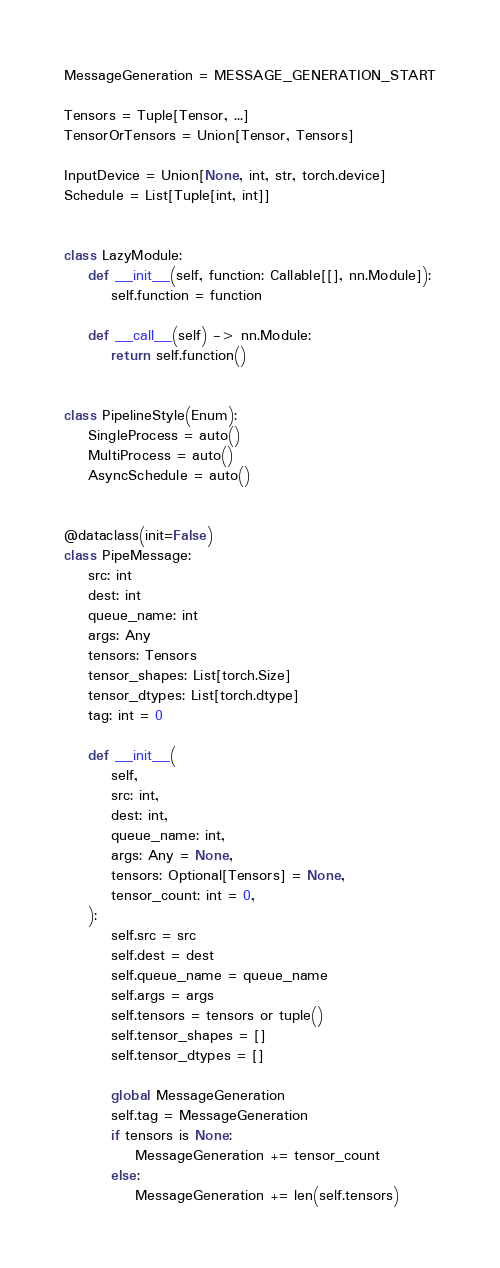Convert code to text. <code><loc_0><loc_0><loc_500><loc_500><_Python_>
MessageGeneration = MESSAGE_GENERATION_START

Tensors = Tuple[Tensor, ...]
TensorOrTensors = Union[Tensor, Tensors]

InputDevice = Union[None, int, str, torch.device]
Schedule = List[Tuple[int, int]]


class LazyModule:
    def __init__(self, function: Callable[[], nn.Module]):
        self.function = function

    def __call__(self) -> nn.Module:
        return self.function()


class PipelineStyle(Enum):
    SingleProcess = auto()
    MultiProcess = auto()
    AsyncSchedule = auto()


@dataclass(init=False)
class PipeMessage:
    src: int
    dest: int
    queue_name: int
    args: Any
    tensors: Tensors
    tensor_shapes: List[torch.Size]
    tensor_dtypes: List[torch.dtype]
    tag: int = 0

    def __init__(
        self,
        src: int,
        dest: int,
        queue_name: int,
        args: Any = None,
        tensors: Optional[Tensors] = None,
        tensor_count: int = 0,
    ):
        self.src = src
        self.dest = dest
        self.queue_name = queue_name
        self.args = args
        self.tensors = tensors or tuple()
        self.tensor_shapes = []
        self.tensor_dtypes = []

        global MessageGeneration
        self.tag = MessageGeneration
        if tensors is None:
            MessageGeneration += tensor_count
        else:
            MessageGeneration += len(self.tensors)
</code> 